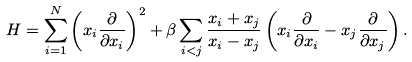Convert formula to latex. <formula><loc_0><loc_0><loc_500><loc_500>H = \sum _ { i = 1 } ^ { N } \left ( x _ { i } \frac { \partial } { \partial x _ { i } } \right ) ^ { 2 } + \beta \sum _ { i < j } \frac { x _ { i } + x _ { j } } { x _ { i } - x _ { j } } \left ( x _ { i } \frac { \partial } { \partial x _ { i } } - x _ { j } \frac { \partial } { \partial x _ { j } } \right ) .</formula> 